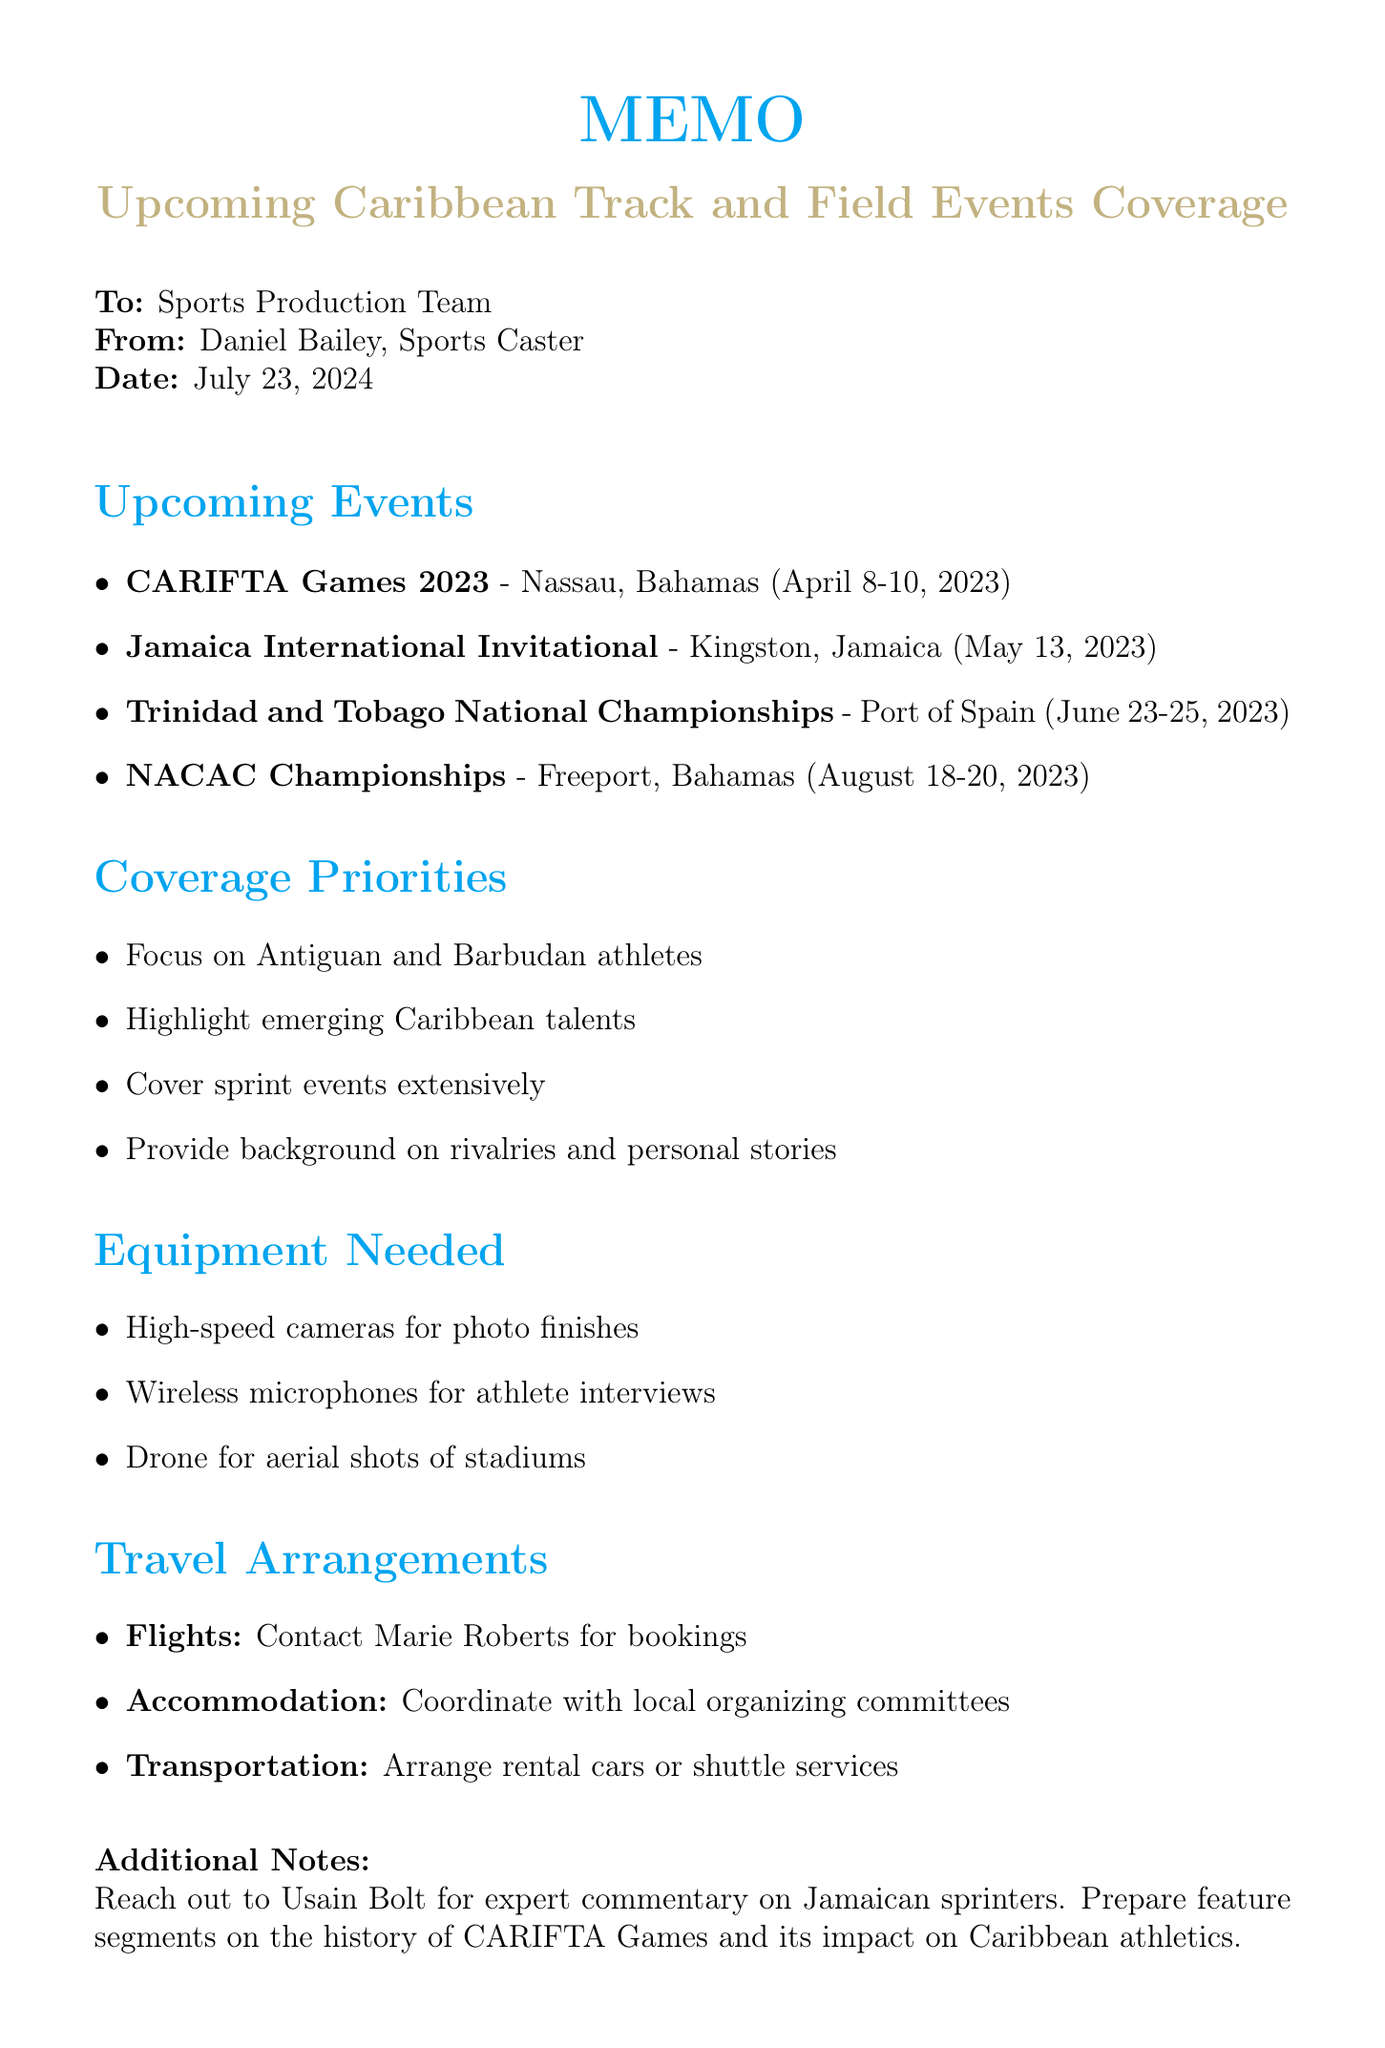What is the title of the memo? The title of the memo is stated at the beginning as "Upcoming Caribbean Track and Field Events Coverage".
Answer: Upcoming Caribbean Track and Field Events Coverage Who is the sender of the memo? The sender is indicated at the top of the memo as Daniel Bailey, Sports Caster.
Answer: Daniel Bailey What are the dates for the CARIFTA Games 2023? The dates for the CARIFTA Games 2023 are listed as April 8-10, 2023.
Answer: April 8-10, 2023 What key athlete is highlighted for the Jamaica International Invitational? Key athletes are mentioned, with Shelly-Ann Fraser-Pryce noted as a prominent figure.
Answer: Shelly-Ann Fraser-Pryce How many events are listed in the memo? The document lists a total of four upcoming events.
Answer: 4 What is the focus for coverage mentioned in the memo? The memo emphasizes focusing on Antiguan and Barbudan athletes as one of the coverage priorities.
Answer: Antiguan and Barbudan athletes Who should be contacted for flight arrangements? The memo states that the travel agent Marie Roberts should be contacted for flight bookings.
Answer: Marie Roberts What equipment is needed for athlete interviews? The document specifies that wireless microphones are needed for athlete interviews.
Answer: Wireless microphones What type of shots is the drone intended for? The memo notes that the drone is intended for aerial shots of stadiums.
Answer: Aerial shots of stadiums 